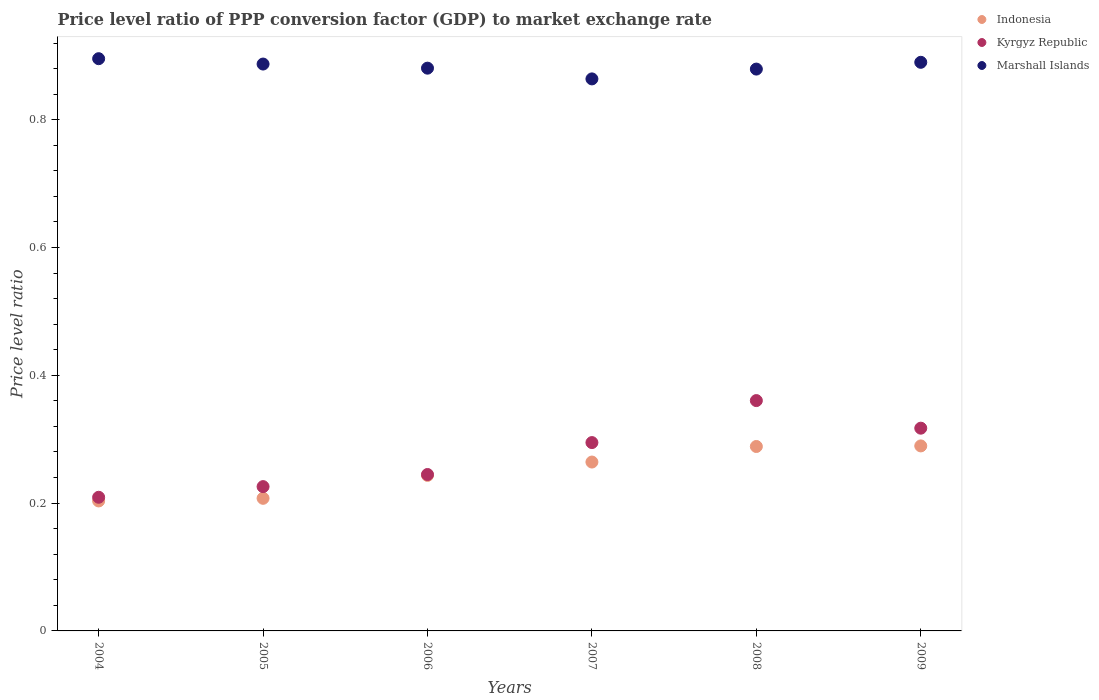How many different coloured dotlines are there?
Provide a succinct answer. 3. Is the number of dotlines equal to the number of legend labels?
Offer a very short reply. Yes. What is the price level ratio in Marshall Islands in 2008?
Provide a short and direct response. 0.88. Across all years, what is the maximum price level ratio in Marshall Islands?
Offer a terse response. 0.9. Across all years, what is the minimum price level ratio in Kyrgyz Republic?
Your response must be concise. 0.21. In which year was the price level ratio in Indonesia minimum?
Ensure brevity in your answer.  2004. What is the total price level ratio in Indonesia in the graph?
Make the answer very short. 1.5. What is the difference between the price level ratio in Marshall Islands in 2004 and that in 2005?
Provide a succinct answer. 0.01. What is the difference between the price level ratio in Kyrgyz Republic in 2006 and the price level ratio in Marshall Islands in 2005?
Your response must be concise. -0.64. What is the average price level ratio in Marshall Islands per year?
Offer a very short reply. 0.88. In the year 2007, what is the difference between the price level ratio in Kyrgyz Republic and price level ratio in Marshall Islands?
Offer a very short reply. -0.57. What is the ratio of the price level ratio in Marshall Islands in 2004 to that in 2006?
Give a very brief answer. 1.02. What is the difference between the highest and the second highest price level ratio in Kyrgyz Republic?
Offer a very short reply. 0.04. What is the difference between the highest and the lowest price level ratio in Indonesia?
Keep it short and to the point. 0.09. In how many years, is the price level ratio in Marshall Islands greater than the average price level ratio in Marshall Islands taken over all years?
Ensure brevity in your answer.  3. Is the sum of the price level ratio in Indonesia in 2007 and 2008 greater than the maximum price level ratio in Kyrgyz Republic across all years?
Offer a very short reply. Yes. Is the price level ratio in Indonesia strictly greater than the price level ratio in Kyrgyz Republic over the years?
Keep it short and to the point. No. How many dotlines are there?
Keep it short and to the point. 3. What is the difference between two consecutive major ticks on the Y-axis?
Give a very brief answer. 0.2. Are the values on the major ticks of Y-axis written in scientific E-notation?
Provide a short and direct response. No. Does the graph contain grids?
Make the answer very short. No. Where does the legend appear in the graph?
Your answer should be compact. Top right. How many legend labels are there?
Your response must be concise. 3. How are the legend labels stacked?
Provide a succinct answer. Vertical. What is the title of the graph?
Offer a terse response. Price level ratio of PPP conversion factor (GDP) to market exchange rate. What is the label or title of the Y-axis?
Keep it short and to the point. Price level ratio. What is the Price level ratio in Indonesia in 2004?
Keep it short and to the point. 0.2. What is the Price level ratio of Kyrgyz Republic in 2004?
Keep it short and to the point. 0.21. What is the Price level ratio of Marshall Islands in 2004?
Your answer should be compact. 0.9. What is the Price level ratio in Indonesia in 2005?
Provide a short and direct response. 0.21. What is the Price level ratio of Kyrgyz Republic in 2005?
Provide a succinct answer. 0.23. What is the Price level ratio of Marshall Islands in 2005?
Your answer should be compact. 0.89. What is the Price level ratio in Indonesia in 2006?
Offer a very short reply. 0.24. What is the Price level ratio in Kyrgyz Republic in 2006?
Offer a terse response. 0.24. What is the Price level ratio in Marshall Islands in 2006?
Offer a terse response. 0.88. What is the Price level ratio of Indonesia in 2007?
Offer a terse response. 0.26. What is the Price level ratio in Kyrgyz Republic in 2007?
Make the answer very short. 0.29. What is the Price level ratio in Marshall Islands in 2007?
Ensure brevity in your answer.  0.86. What is the Price level ratio in Indonesia in 2008?
Offer a very short reply. 0.29. What is the Price level ratio in Kyrgyz Republic in 2008?
Ensure brevity in your answer.  0.36. What is the Price level ratio of Marshall Islands in 2008?
Keep it short and to the point. 0.88. What is the Price level ratio of Indonesia in 2009?
Your response must be concise. 0.29. What is the Price level ratio of Kyrgyz Republic in 2009?
Offer a very short reply. 0.32. What is the Price level ratio in Marshall Islands in 2009?
Provide a short and direct response. 0.89. Across all years, what is the maximum Price level ratio of Indonesia?
Keep it short and to the point. 0.29. Across all years, what is the maximum Price level ratio in Kyrgyz Republic?
Provide a succinct answer. 0.36. Across all years, what is the maximum Price level ratio of Marshall Islands?
Your answer should be compact. 0.9. Across all years, what is the minimum Price level ratio of Indonesia?
Ensure brevity in your answer.  0.2. Across all years, what is the minimum Price level ratio of Kyrgyz Republic?
Ensure brevity in your answer.  0.21. Across all years, what is the minimum Price level ratio in Marshall Islands?
Offer a very short reply. 0.86. What is the total Price level ratio in Indonesia in the graph?
Provide a short and direct response. 1.5. What is the total Price level ratio of Kyrgyz Republic in the graph?
Make the answer very short. 1.65. What is the total Price level ratio in Marshall Islands in the graph?
Keep it short and to the point. 5.3. What is the difference between the Price level ratio of Indonesia in 2004 and that in 2005?
Provide a succinct answer. -0. What is the difference between the Price level ratio of Kyrgyz Republic in 2004 and that in 2005?
Give a very brief answer. -0.02. What is the difference between the Price level ratio of Marshall Islands in 2004 and that in 2005?
Give a very brief answer. 0.01. What is the difference between the Price level ratio of Indonesia in 2004 and that in 2006?
Offer a very short reply. -0.04. What is the difference between the Price level ratio in Kyrgyz Republic in 2004 and that in 2006?
Make the answer very short. -0.04. What is the difference between the Price level ratio of Marshall Islands in 2004 and that in 2006?
Give a very brief answer. 0.01. What is the difference between the Price level ratio of Indonesia in 2004 and that in 2007?
Offer a very short reply. -0.06. What is the difference between the Price level ratio in Kyrgyz Republic in 2004 and that in 2007?
Keep it short and to the point. -0.09. What is the difference between the Price level ratio in Marshall Islands in 2004 and that in 2007?
Provide a short and direct response. 0.03. What is the difference between the Price level ratio in Indonesia in 2004 and that in 2008?
Ensure brevity in your answer.  -0.09. What is the difference between the Price level ratio in Kyrgyz Republic in 2004 and that in 2008?
Keep it short and to the point. -0.15. What is the difference between the Price level ratio of Marshall Islands in 2004 and that in 2008?
Offer a terse response. 0.02. What is the difference between the Price level ratio of Indonesia in 2004 and that in 2009?
Offer a very short reply. -0.09. What is the difference between the Price level ratio of Kyrgyz Republic in 2004 and that in 2009?
Offer a very short reply. -0.11. What is the difference between the Price level ratio in Marshall Islands in 2004 and that in 2009?
Keep it short and to the point. 0.01. What is the difference between the Price level ratio of Indonesia in 2005 and that in 2006?
Keep it short and to the point. -0.04. What is the difference between the Price level ratio of Kyrgyz Republic in 2005 and that in 2006?
Offer a terse response. -0.02. What is the difference between the Price level ratio in Marshall Islands in 2005 and that in 2006?
Ensure brevity in your answer.  0.01. What is the difference between the Price level ratio of Indonesia in 2005 and that in 2007?
Offer a very short reply. -0.06. What is the difference between the Price level ratio of Kyrgyz Republic in 2005 and that in 2007?
Provide a short and direct response. -0.07. What is the difference between the Price level ratio in Marshall Islands in 2005 and that in 2007?
Offer a very short reply. 0.02. What is the difference between the Price level ratio of Indonesia in 2005 and that in 2008?
Your response must be concise. -0.08. What is the difference between the Price level ratio of Kyrgyz Republic in 2005 and that in 2008?
Keep it short and to the point. -0.13. What is the difference between the Price level ratio of Marshall Islands in 2005 and that in 2008?
Your answer should be compact. 0.01. What is the difference between the Price level ratio in Indonesia in 2005 and that in 2009?
Your answer should be compact. -0.08. What is the difference between the Price level ratio in Kyrgyz Republic in 2005 and that in 2009?
Keep it short and to the point. -0.09. What is the difference between the Price level ratio in Marshall Islands in 2005 and that in 2009?
Your response must be concise. -0. What is the difference between the Price level ratio of Indonesia in 2006 and that in 2007?
Provide a succinct answer. -0.02. What is the difference between the Price level ratio in Kyrgyz Republic in 2006 and that in 2007?
Keep it short and to the point. -0.05. What is the difference between the Price level ratio of Marshall Islands in 2006 and that in 2007?
Provide a succinct answer. 0.02. What is the difference between the Price level ratio of Indonesia in 2006 and that in 2008?
Ensure brevity in your answer.  -0.05. What is the difference between the Price level ratio of Kyrgyz Republic in 2006 and that in 2008?
Make the answer very short. -0.12. What is the difference between the Price level ratio in Marshall Islands in 2006 and that in 2008?
Make the answer very short. 0. What is the difference between the Price level ratio of Indonesia in 2006 and that in 2009?
Offer a terse response. -0.05. What is the difference between the Price level ratio of Kyrgyz Republic in 2006 and that in 2009?
Your answer should be very brief. -0.07. What is the difference between the Price level ratio of Marshall Islands in 2006 and that in 2009?
Your answer should be very brief. -0.01. What is the difference between the Price level ratio of Indonesia in 2007 and that in 2008?
Provide a succinct answer. -0.02. What is the difference between the Price level ratio of Kyrgyz Republic in 2007 and that in 2008?
Your answer should be very brief. -0.07. What is the difference between the Price level ratio of Marshall Islands in 2007 and that in 2008?
Your answer should be compact. -0.02. What is the difference between the Price level ratio of Indonesia in 2007 and that in 2009?
Your response must be concise. -0.03. What is the difference between the Price level ratio of Kyrgyz Republic in 2007 and that in 2009?
Your answer should be very brief. -0.02. What is the difference between the Price level ratio of Marshall Islands in 2007 and that in 2009?
Provide a succinct answer. -0.03. What is the difference between the Price level ratio of Indonesia in 2008 and that in 2009?
Offer a very short reply. -0. What is the difference between the Price level ratio in Kyrgyz Republic in 2008 and that in 2009?
Make the answer very short. 0.04. What is the difference between the Price level ratio of Marshall Islands in 2008 and that in 2009?
Keep it short and to the point. -0.01. What is the difference between the Price level ratio of Indonesia in 2004 and the Price level ratio of Kyrgyz Republic in 2005?
Keep it short and to the point. -0.02. What is the difference between the Price level ratio in Indonesia in 2004 and the Price level ratio in Marshall Islands in 2005?
Your answer should be compact. -0.68. What is the difference between the Price level ratio in Kyrgyz Republic in 2004 and the Price level ratio in Marshall Islands in 2005?
Your answer should be compact. -0.68. What is the difference between the Price level ratio of Indonesia in 2004 and the Price level ratio of Kyrgyz Republic in 2006?
Your answer should be compact. -0.04. What is the difference between the Price level ratio in Indonesia in 2004 and the Price level ratio in Marshall Islands in 2006?
Your answer should be very brief. -0.68. What is the difference between the Price level ratio in Kyrgyz Republic in 2004 and the Price level ratio in Marshall Islands in 2006?
Provide a succinct answer. -0.67. What is the difference between the Price level ratio in Indonesia in 2004 and the Price level ratio in Kyrgyz Republic in 2007?
Ensure brevity in your answer.  -0.09. What is the difference between the Price level ratio in Indonesia in 2004 and the Price level ratio in Marshall Islands in 2007?
Keep it short and to the point. -0.66. What is the difference between the Price level ratio of Kyrgyz Republic in 2004 and the Price level ratio of Marshall Islands in 2007?
Your answer should be very brief. -0.65. What is the difference between the Price level ratio of Indonesia in 2004 and the Price level ratio of Kyrgyz Republic in 2008?
Provide a succinct answer. -0.16. What is the difference between the Price level ratio of Indonesia in 2004 and the Price level ratio of Marshall Islands in 2008?
Your answer should be compact. -0.68. What is the difference between the Price level ratio of Kyrgyz Republic in 2004 and the Price level ratio of Marshall Islands in 2008?
Offer a very short reply. -0.67. What is the difference between the Price level ratio of Indonesia in 2004 and the Price level ratio of Kyrgyz Republic in 2009?
Ensure brevity in your answer.  -0.11. What is the difference between the Price level ratio of Indonesia in 2004 and the Price level ratio of Marshall Islands in 2009?
Ensure brevity in your answer.  -0.69. What is the difference between the Price level ratio in Kyrgyz Republic in 2004 and the Price level ratio in Marshall Islands in 2009?
Your answer should be compact. -0.68. What is the difference between the Price level ratio in Indonesia in 2005 and the Price level ratio in Kyrgyz Republic in 2006?
Your answer should be very brief. -0.04. What is the difference between the Price level ratio in Indonesia in 2005 and the Price level ratio in Marshall Islands in 2006?
Make the answer very short. -0.67. What is the difference between the Price level ratio of Kyrgyz Republic in 2005 and the Price level ratio of Marshall Islands in 2006?
Your answer should be very brief. -0.65. What is the difference between the Price level ratio of Indonesia in 2005 and the Price level ratio of Kyrgyz Republic in 2007?
Give a very brief answer. -0.09. What is the difference between the Price level ratio in Indonesia in 2005 and the Price level ratio in Marshall Islands in 2007?
Offer a very short reply. -0.66. What is the difference between the Price level ratio of Kyrgyz Republic in 2005 and the Price level ratio of Marshall Islands in 2007?
Give a very brief answer. -0.64. What is the difference between the Price level ratio of Indonesia in 2005 and the Price level ratio of Kyrgyz Republic in 2008?
Provide a short and direct response. -0.15. What is the difference between the Price level ratio of Indonesia in 2005 and the Price level ratio of Marshall Islands in 2008?
Make the answer very short. -0.67. What is the difference between the Price level ratio in Kyrgyz Republic in 2005 and the Price level ratio in Marshall Islands in 2008?
Offer a terse response. -0.65. What is the difference between the Price level ratio in Indonesia in 2005 and the Price level ratio in Kyrgyz Republic in 2009?
Make the answer very short. -0.11. What is the difference between the Price level ratio of Indonesia in 2005 and the Price level ratio of Marshall Islands in 2009?
Your answer should be compact. -0.68. What is the difference between the Price level ratio of Kyrgyz Republic in 2005 and the Price level ratio of Marshall Islands in 2009?
Give a very brief answer. -0.66. What is the difference between the Price level ratio in Indonesia in 2006 and the Price level ratio in Kyrgyz Republic in 2007?
Your answer should be very brief. -0.05. What is the difference between the Price level ratio in Indonesia in 2006 and the Price level ratio in Marshall Islands in 2007?
Your answer should be very brief. -0.62. What is the difference between the Price level ratio in Kyrgyz Republic in 2006 and the Price level ratio in Marshall Islands in 2007?
Make the answer very short. -0.62. What is the difference between the Price level ratio in Indonesia in 2006 and the Price level ratio in Kyrgyz Republic in 2008?
Give a very brief answer. -0.12. What is the difference between the Price level ratio of Indonesia in 2006 and the Price level ratio of Marshall Islands in 2008?
Ensure brevity in your answer.  -0.64. What is the difference between the Price level ratio in Kyrgyz Republic in 2006 and the Price level ratio in Marshall Islands in 2008?
Ensure brevity in your answer.  -0.63. What is the difference between the Price level ratio of Indonesia in 2006 and the Price level ratio of Kyrgyz Republic in 2009?
Your answer should be very brief. -0.07. What is the difference between the Price level ratio of Indonesia in 2006 and the Price level ratio of Marshall Islands in 2009?
Offer a very short reply. -0.65. What is the difference between the Price level ratio in Kyrgyz Republic in 2006 and the Price level ratio in Marshall Islands in 2009?
Offer a terse response. -0.65. What is the difference between the Price level ratio in Indonesia in 2007 and the Price level ratio in Kyrgyz Republic in 2008?
Give a very brief answer. -0.1. What is the difference between the Price level ratio of Indonesia in 2007 and the Price level ratio of Marshall Islands in 2008?
Provide a succinct answer. -0.61. What is the difference between the Price level ratio of Kyrgyz Republic in 2007 and the Price level ratio of Marshall Islands in 2008?
Provide a succinct answer. -0.58. What is the difference between the Price level ratio of Indonesia in 2007 and the Price level ratio of Kyrgyz Republic in 2009?
Provide a succinct answer. -0.05. What is the difference between the Price level ratio of Indonesia in 2007 and the Price level ratio of Marshall Islands in 2009?
Offer a terse response. -0.63. What is the difference between the Price level ratio in Kyrgyz Republic in 2007 and the Price level ratio in Marshall Islands in 2009?
Provide a short and direct response. -0.6. What is the difference between the Price level ratio in Indonesia in 2008 and the Price level ratio in Kyrgyz Republic in 2009?
Ensure brevity in your answer.  -0.03. What is the difference between the Price level ratio of Indonesia in 2008 and the Price level ratio of Marshall Islands in 2009?
Provide a short and direct response. -0.6. What is the difference between the Price level ratio in Kyrgyz Republic in 2008 and the Price level ratio in Marshall Islands in 2009?
Ensure brevity in your answer.  -0.53. What is the average Price level ratio in Indonesia per year?
Your answer should be very brief. 0.25. What is the average Price level ratio of Kyrgyz Republic per year?
Your answer should be compact. 0.28. What is the average Price level ratio in Marshall Islands per year?
Your answer should be very brief. 0.88. In the year 2004, what is the difference between the Price level ratio of Indonesia and Price level ratio of Kyrgyz Republic?
Offer a terse response. -0.01. In the year 2004, what is the difference between the Price level ratio of Indonesia and Price level ratio of Marshall Islands?
Your answer should be very brief. -0.69. In the year 2004, what is the difference between the Price level ratio in Kyrgyz Republic and Price level ratio in Marshall Islands?
Offer a terse response. -0.69. In the year 2005, what is the difference between the Price level ratio of Indonesia and Price level ratio of Kyrgyz Republic?
Your answer should be very brief. -0.02. In the year 2005, what is the difference between the Price level ratio in Indonesia and Price level ratio in Marshall Islands?
Provide a succinct answer. -0.68. In the year 2005, what is the difference between the Price level ratio in Kyrgyz Republic and Price level ratio in Marshall Islands?
Your answer should be very brief. -0.66. In the year 2006, what is the difference between the Price level ratio of Indonesia and Price level ratio of Kyrgyz Republic?
Your response must be concise. -0. In the year 2006, what is the difference between the Price level ratio in Indonesia and Price level ratio in Marshall Islands?
Your answer should be compact. -0.64. In the year 2006, what is the difference between the Price level ratio in Kyrgyz Republic and Price level ratio in Marshall Islands?
Ensure brevity in your answer.  -0.64. In the year 2007, what is the difference between the Price level ratio in Indonesia and Price level ratio in Kyrgyz Republic?
Offer a very short reply. -0.03. In the year 2007, what is the difference between the Price level ratio of Indonesia and Price level ratio of Marshall Islands?
Your answer should be compact. -0.6. In the year 2007, what is the difference between the Price level ratio in Kyrgyz Republic and Price level ratio in Marshall Islands?
Keep it short and to the point. -0.57. In the year 2008, what is the difference between the Price level ratio of Indonesia and Price level ratio of Kyrgyz Republic?
Provide a short and direct response. -0.07. In the year 2008, what is the difference between the Price level ratio of Indonesia and Price level ratio of Marshall Islands?
Ensure brevity in your answer.  -0.59. In the year 2008, what is the difference between the Price level ratio in Kyrgyz Republic and Price level ratio in Marshall Islands?
Your response must be concise. -0.52. In the year 2009, what is the difference between the Price level ratio in Indonesia and Price level ratio in Kyrgyz Republic?
Offer a very short reply. -0.03. In the year 2009, what is the difference between the Price level ratio of Indonesia and Price level ratio of Marshall Islands?
Keep it short and to the point. -0.6. In the year 2009, what is the difference between the Price level ratio of Kyrgyz Republic and Price level ratio of Marshall Islands?
Give a very brief answer. -0.57. What is the ratio of the Price level ratio of Indonesia in 2004 to that in 2005?
Your answer should be compact. 0.98. What is the ratio of the Price level ratio in Kyrgyz Republic in 2004 to that in 2005?
Provide a succinct answer. 0.93. What is the ratio of the Price level ratio in Marshall Islands in 2004 to that in 2005?
Your answer should be compact. 1.01. What is the ratio of the Price level ratio of Indonesia in 2004 to that in 2006?
Offer a very short reply. 0.84. What is the ratio of the Price level ratio in Kyrgyz Republic in 2004 to that in 2006?
Offer a very short reply. 0.85. What is the ratio of the Price level ratio of Marshall Islands in 2004 to that in 2006?
Your response must be concise. 1.02. What is the ratio of the Price level ratio in Indonesia in 2004 to that in 2007?
Offer a very short reply. 0.77. What is the ratio of the Price level ratio of Kyrgyz Republic in 2004 to that in 2007?
Provide a succinct answer. 0.71. What is the ratio of the Price level ratio in Marshall Islands in 2004 to that in 2007?
Keep it short and to the point. 1.04. What is the ratio of the Price level ratio in Indonesia in 2004 to that in 2008?
Provide a succinct answer. 0.7. What is the ratio of the Price level ratio of Kyrgyz Republic in 2004 to that in 2008?
Give a very brief answer. 0.58. What is the ratio of the Price level ratio of Marshall Islands in 2004 to that in 2008?
Ensure brevity in your answer.  1.02. What is the ratio of the Price level ratio in Indonesia in 2004 to that in 2009?
Ensure brevity in your answer.  0.7. What is the ratio of the Price level ratio in Kyrgyz Republic in 2004 to that in 2009?
Offer a terse response. 0.66. What is the ratio of the Price level ratio in Marshall Islands in 2004 to that in 2009?
Your answer should be very brief. 1.01. What is the ratio of the Price level ratio of Indonesia in 2005 to that in 2006?
Your response must be concise. 0.85. What is the ratio of the Price level ratio in Kyrgyz Republic in 2005 to that in 2006?
Your answer should be compact. 0.92. What is the ratio of the Price level ratio in Marshall Islands in 2005 to that in 2006?
Keep it short and to the point. 1.01. What is the ratio of the Price level ratio of Indonesia in 2005 to that in 2007?
Offer a terse response. 0.79. What is the ratio of the Price level ratio in Kyrgyz Republic in 2005 to that in 2007?
Your response must be concise. 0.77. What is the ratio of the Price level ratio of Marshall Islands in 2005 to that in 2007?
Offer a terse response. 1.03. What is the ratio of the Price level ratio of Indonesia in 2005 to that in 2008?
Keep it short and to the point. 0.72. What is the ratio of the Price level ratio of Kyrgyz Republic in 2005 to that in 2008?
Your answer should be very brief. 0.63. What is the ratio of the Price level ratio of Indonesia in 2005 to that in 2009?
Provide a succinct answer. 0.72. What is the ratio of the Price level ratio in Kyrgyz Republic in 2005 to that in 2009?
Your answer should be very brief. 0.71. What is the ratio of the Price level ratio in Marshall Islands in 2005 to that in 2009?
Keep it short and to the point. 1. What is the ratio of the Price level ratio in Indonesia in 2006 to that in 2007?
Provide a short and direct response. 0.92. What is the ratio of the Price level ratio of Kyrgyz Republic in 2006 to that in 2007?
Offer a very short reply. 0.83. What is the ratio of the Price level ratio in Marshall Islands in 2006 to that in 2007?
Keep it short and to the point. 1.02. What is the ratio of the Price level ratio in Indonesia in 2006 to that in 2008?
Offer a terse response. 0.84. What is the ratio of the Price level ratio in Kyrgyz Republic in 2006 to that in 2008?
Keep it short and to the point. 0.68. What is the ratio of the Price level ratio in Marshall Islands in 2006 to that in 2008?
Your response must be concise. 1. What is the ratio of the Price level ratio in Indonesia in 2006 to that in 2009?
Your response must be concise. 0.84. What is the ratio of the Price level ratio in Kyrgyz Republic in 2006 to that in 2009?
Your answer should be very brief. 0.77. What is the ratio of the Price level ratio in Marshall Islands in 2006 to that in 2009?
Your response must be concise. 0.99. What is the ratio of the Price level ratio of Indonesia in 2007 to that in 2008?
Ensure brevity in your answer.  0.92. What is the ratio of the Price level ratio of Kyrgyz Republic in 2007 to that in 2008?
Your response must be concise. 0.82. What is the ratio of the Price level ratio in Marshall Islands in 2007 to that in 2008?
Your answer should be very brief. 0.98. What is the ratio of the Price level ratio of Indonesia in 2007 to that in 2009?
Give a very brief answer. 0.91. What is the ratio of the Price level ratio of Kyrgyz Republic in 2007 to that in 2009?
Make the answer very short. 0.93. What is the ratio of the Price level ratio of Marshall Islands in 2007 to that in 2009?
Offer a very short reply. 0.97. What is the ratio of the Price level ratio of Indonesia in 2008 to that in 2009?
Ensure brevity in your answer.  1. What is the ratio of the Price level ratio in Kyrgyz Republic in 2008 to that in 2009?
Provide a short and direct response. 1.14. What is the difference between the highest and the second highest Price level ratio of Indonesia?
Make the answer very short. 0. What is the difference between the highest and the second highest Price level ratio in Kyrgyz Republic?
Offer a terse response. 0.04. What is the difference between the highest and the second highest Price level ratio of Marshall Islands?
Make the answer very short. 0.01. What is the difference between the highest and the lowest Price level ratio in Indonesia?
Offer a terse response. 0.09. What is the difference between the highest and the lowest Price level ratio of Kyrgyz Republic?
Your answer should be very brief. 0.15. What is the difference between the highest and the lowest Price level ratio of Marshall Islands?
Ensure brevity in your answer.  0.03. 